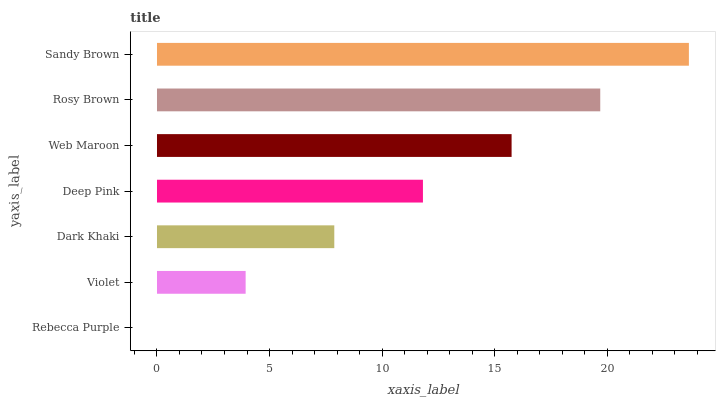Is Rebecca Purple the minimum?
Answer yes or no. Yes. Is Sandy Brown the maximum?
Answer yes or no. Yes. Is Violet the minimum?
Answer yes or no. No. Is Violet the maximum?
Answer yes or no. No. Is Violet greater than Rebecca Purple?
Answer yes or no. Yes. Is Rebecca Purple less than Violet?
Answer yes or no. Yes. Is Rebecca Purple greater than Violet?
Answer yes or no. No. Is Violet less than Rebecca Purple?
Answer yes or no. No. Is Deep Pink the high median?
Answer yes or no. Yes. Is Deep Pink the low median?
Answer yes or no. Yes. Is Dark Khaki the high median?
Answer yes or no. No. Is Rebecca Purple the low median?
Answer yes or no. No. 